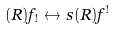Convert formula to latex. <formula><loc_0><loc_0><loc_500><loc_500>( R ) f _ { ! } \leftrightarrow s ( R ) f ^ { ! }</formula> 